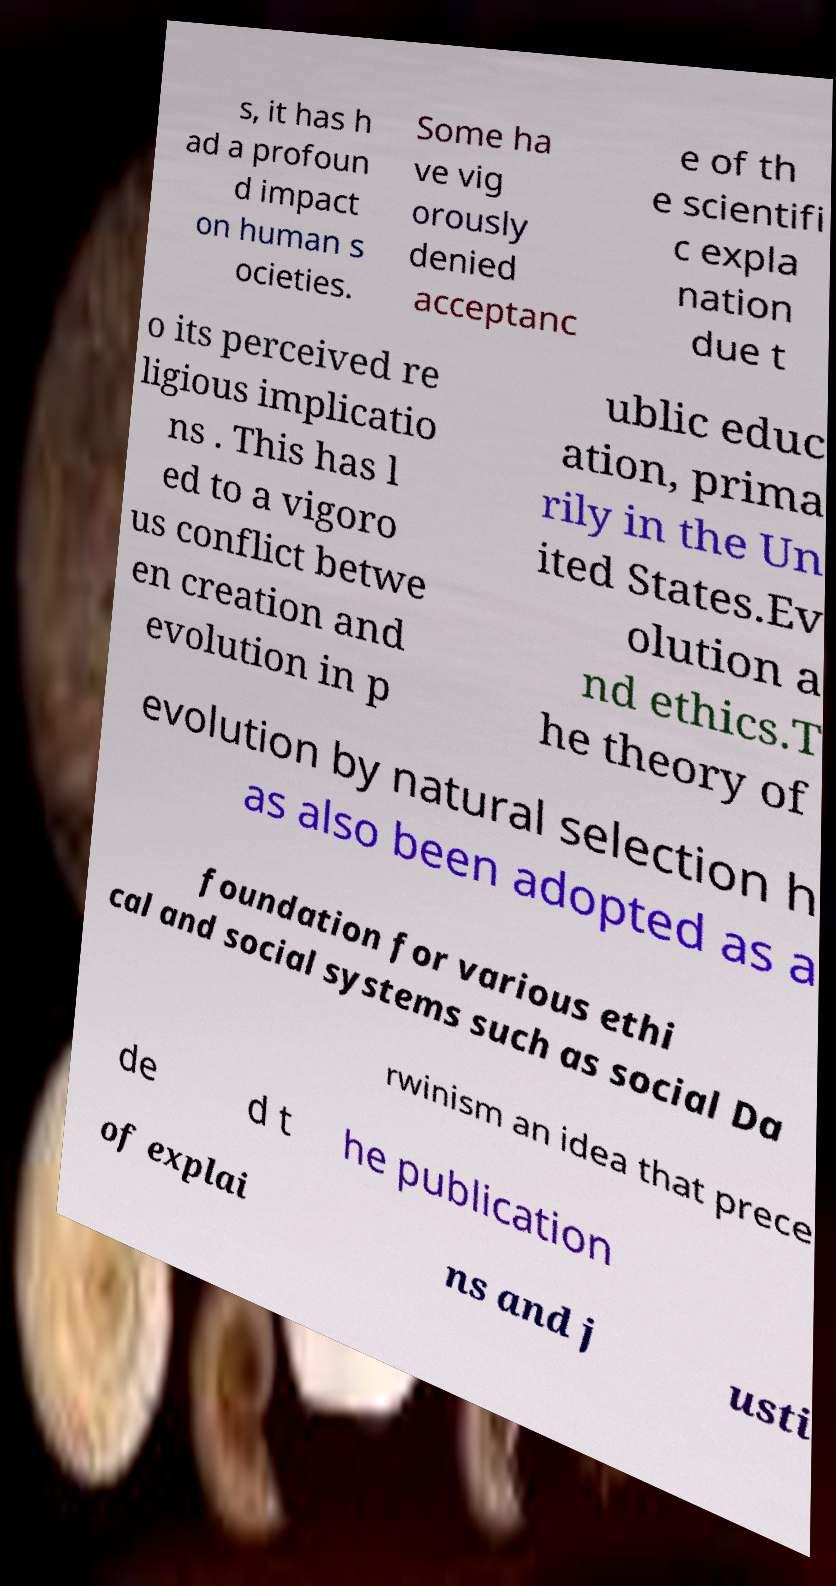I need the written content from this picture converted into text. Can you do that? s, it has h ad a profoun d impact on human s ocieties. Some ha ve vig orously denied acceptanc e of th e scientifi c expla nation due t o its perceived re ligious implicatio ns . This has l ed to a vigoro us conflict betwe en creation and evolution in p ublic educ ation, prima rily in the Un ited States.Ev olution a nd ethics.T he theory of evolution by natural selection h as also been adopted as a foundation for various ethi cal and social systems such as social Da rwinism an idea that prece de d t he publication of explai ns and j usti 